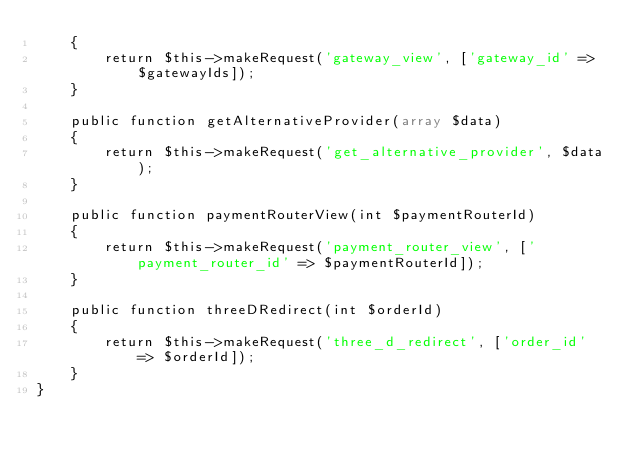Convert code to text. <code><loc_0><loc_0><loc_500><loc_500><_PHP_>    {
        return $this->makeRequest('gateway_view', ['gateway_id' => $gatewayIds]);
    }

    public function getAlternativeProvider(array $data)
    {
        return $this->makeRequest('get_alternative_provider', $data);
    }

    public function paymentRouterView(int $paymentRouterId)
    {
        return $this->makeRequest('payment_router_view', ['payment_router_id' => $paymentRouterId]);
    }

    public function threeDRedirect(int $orderId)
    {
        return $this->makeRequest('three_d_redirect', ['order_id' => $orderId]);
    }
}</code> 